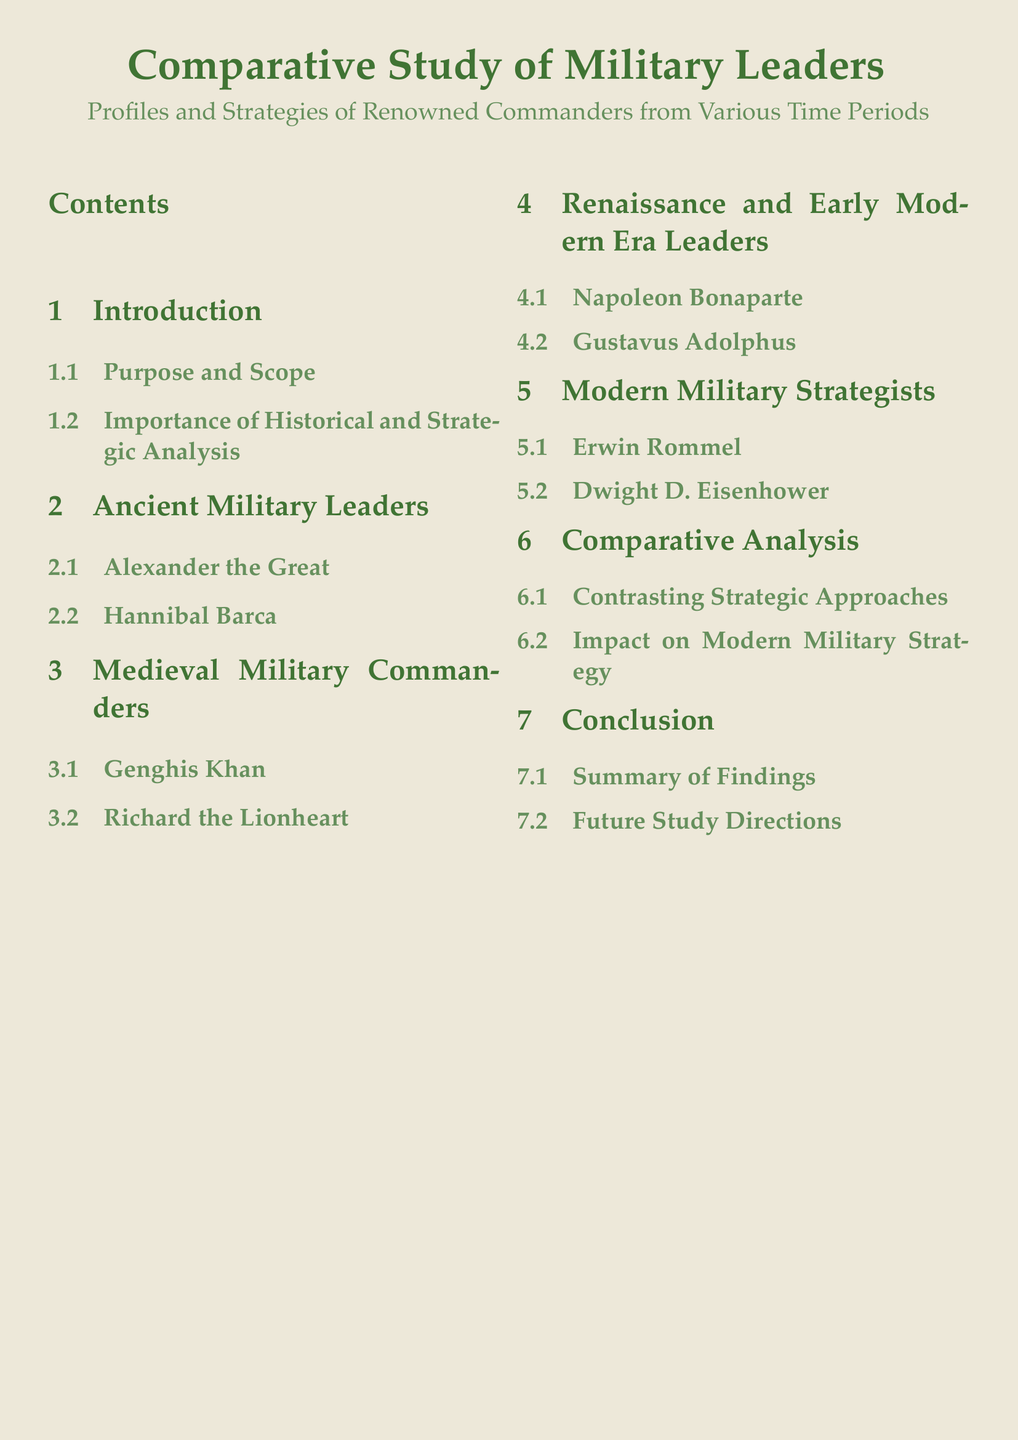What is the main focus of the document? The document focuses on military leaders and their strategies throughout history.
Answer: Comparative Study of Military Leaders How many sections are there in the document? The document contains six sections including the introduction and conclusion.
Answer: Six Who is featured as an Ancient Military Leader? The document lists Alexander the Great as one of the ancient military leaders.
Answer: Alexander the Great Which military commander is associated with the Renaissance and Early Modern Era? The document identifies Napoleon Bonaparte as a leader from this period.
Answer: Napoleon Bonaparte What is the last subsection in the conclusion? The last subsection in the conclusion highlights future avenues for research.
Answer: Future Study Directions What type of analysis is conducted in the comparative analysis section? The document contrasts different strategic approaches taken by military leaders.
Answer: Contrasting Strategic Approaches Who is listed as a Modern Military Strategist? The document mentions Erwin Rommel among modern military strategists.
Answer: Erwin Rommel What is emphasized in the Purpose and Scope subsection? This subsection discusses the objectives of the study and its intended reach.
Answer: Importance of Historical and Strategic Analysis 